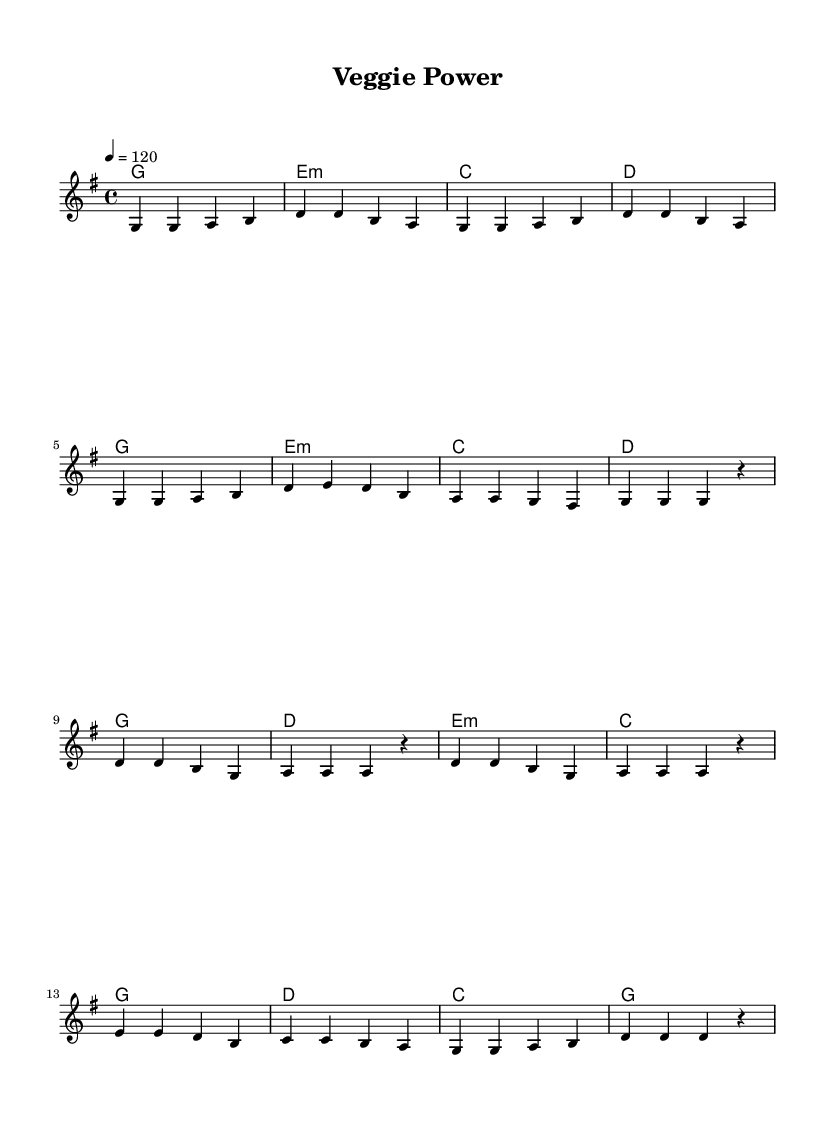what is the key signature of this music? The key signature is determined by the number of sharps or flats indicated at the beginning of the staff. In this case, it shows one sharp (F#), which means the key signature is G major.
Answer: G major what is the time signature of this music? The time signature is represented by the fraction at the beginning of the score. Here, it shows 4 over 4, meaning there are four beats per measure and the quarter note receives one beat.
Answer: 4/4 what is the tempo marking for this music? The tempo is indicated by a number followed by "=" and a note value. In this score, it states "4 = 120," meaning the quarter note should be played at 120 beats per minute.
Answer: 120 how many measures are in the verse section? The verse section is made up of eight measures as indicated by the grouping of notes. Counting from the start until the repeat, there are eight distinct sets of notes.
Answer: 8 which chord appears most frequently in the chorus? By analyzing the chord changes in the chorus, we see that the G chord appears twice in succession, making it the most frequently occurring chord.
Answer: G what is the total number of distinct chords used in the piece? The distinct chords are listed in the harmonies section. Counting the unique chords listed, there are five different chords (G, E minor, C, D, A).
Answer: 5 how does the melody start in the verse section? The beginning of the verse is marked by the first few notes in the melody line. It starts on the note G and is followed by another G note, indicating the initial melodic motif.
Answer: G 